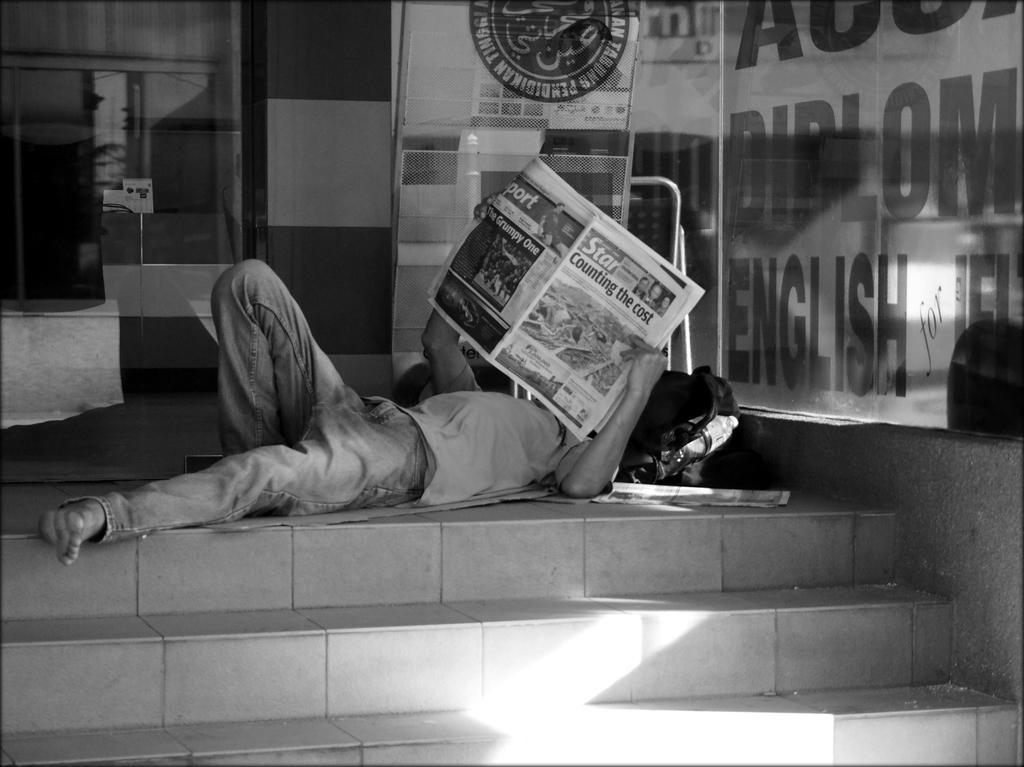Can you describe this image briefly? In this picture we can see a person, bag, bottle, steps, glass with some text on it and this person is holding a newspaper. 